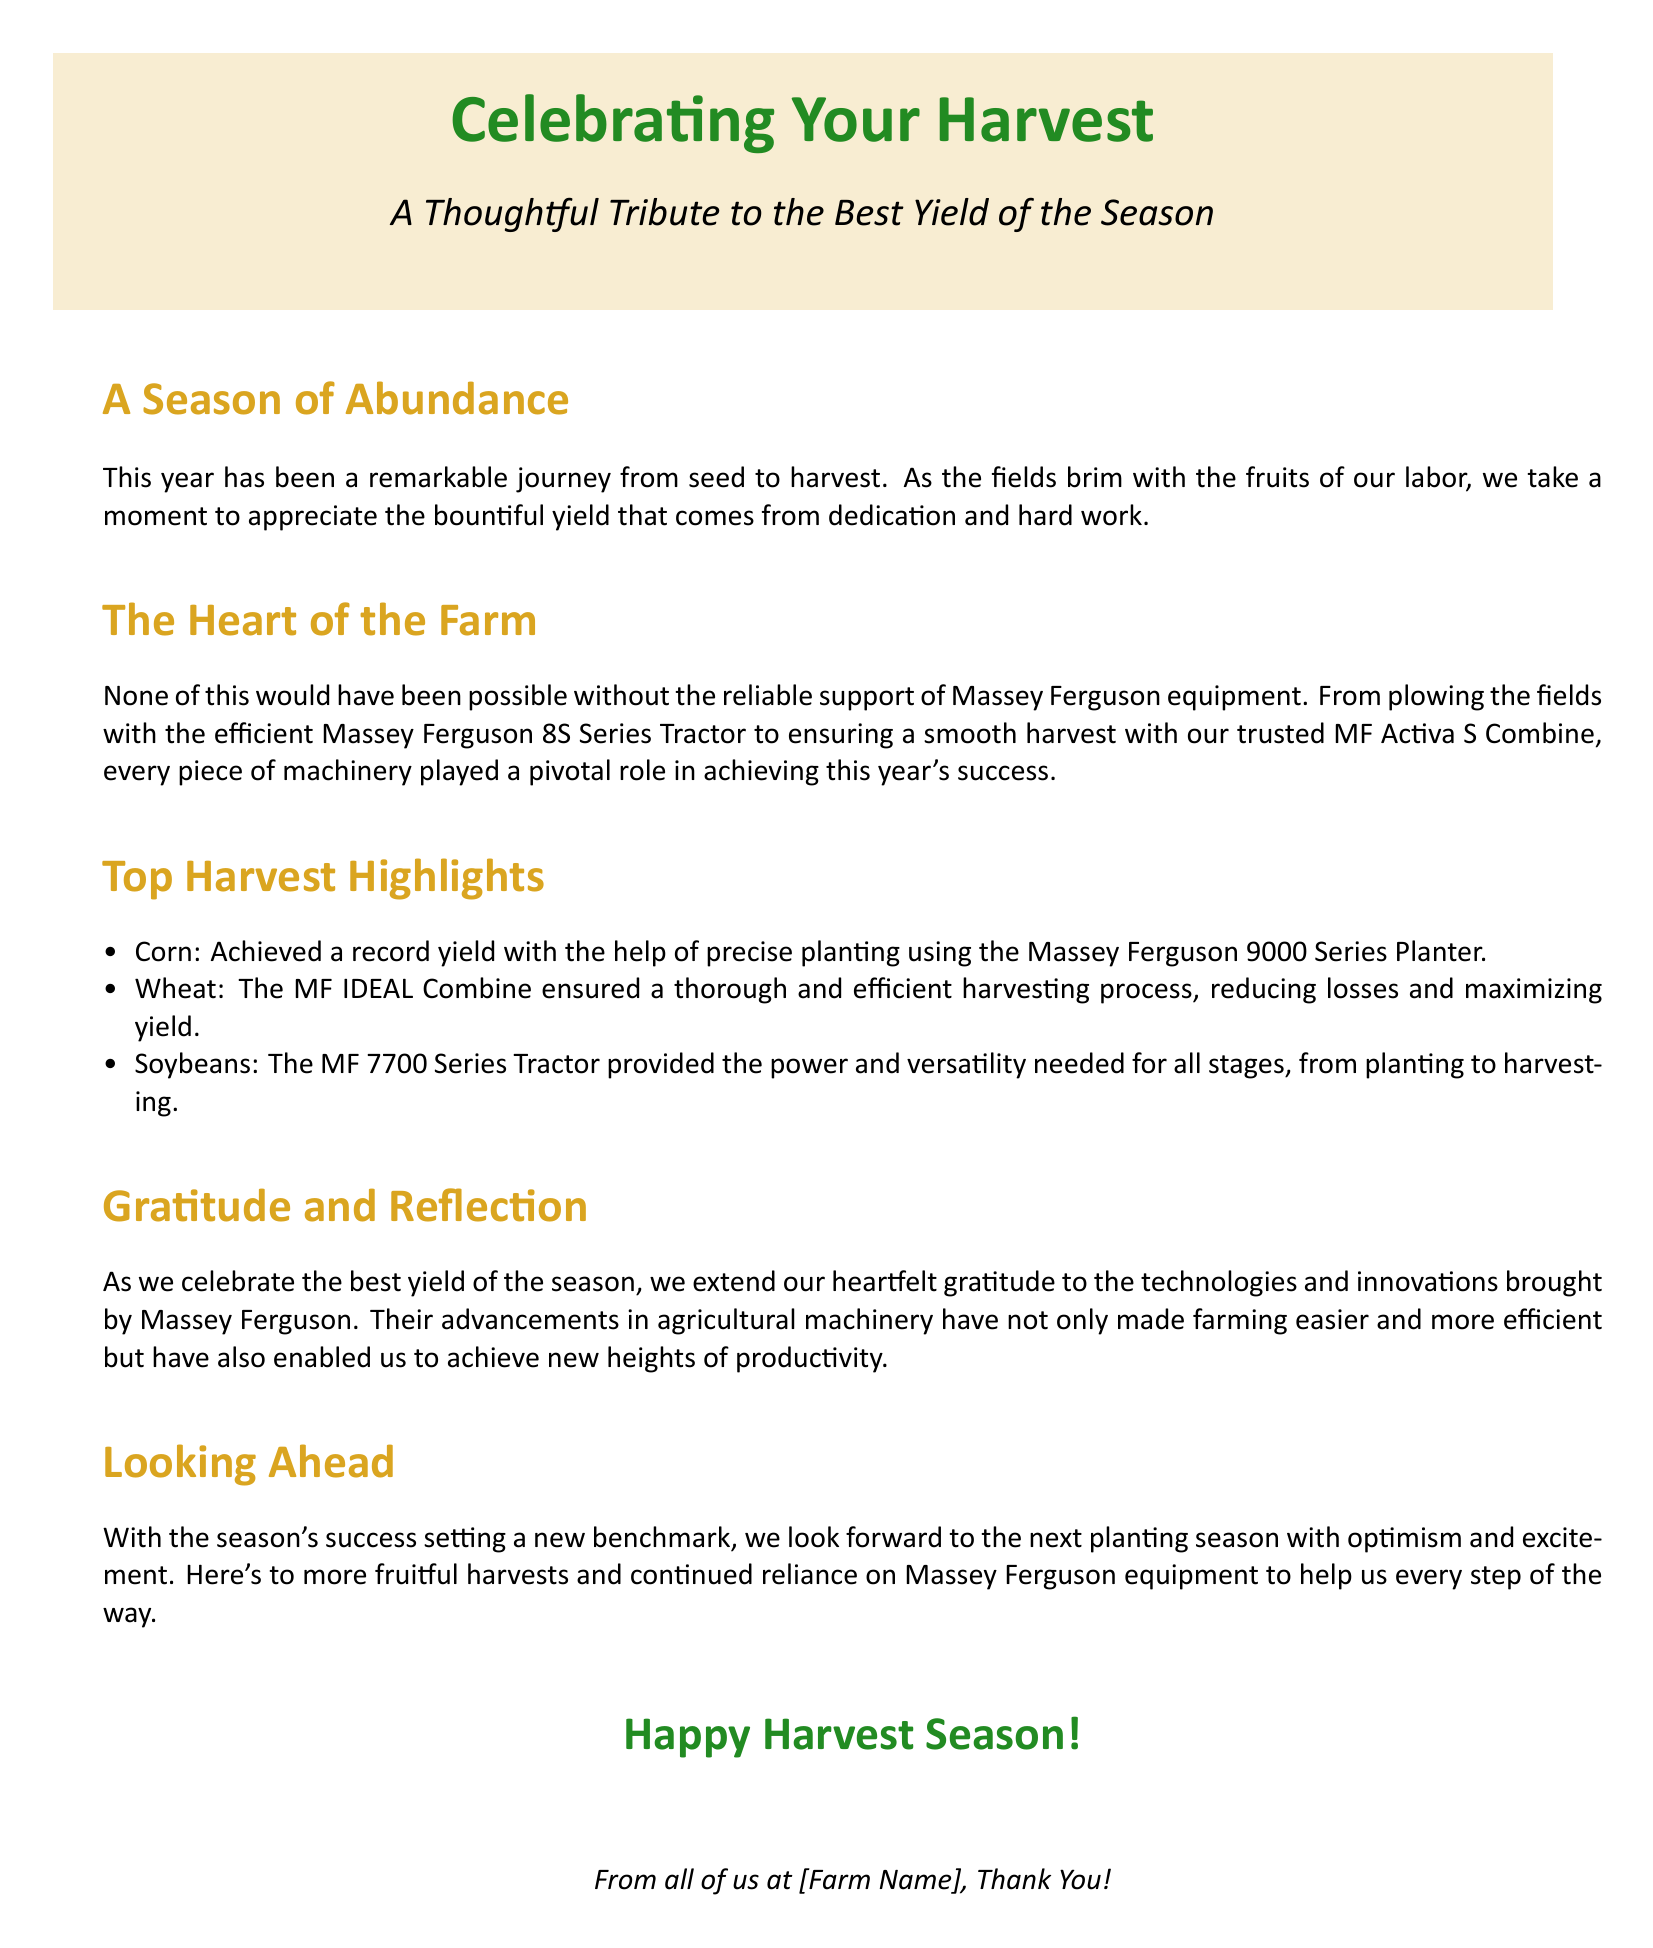What is the title of the card? The title is prominently displayed at the top of the document.
Answer: Celebrating Your Harvest What is the main color theme of the card? The card uses specific colors mentioned throughout the content.
Answer: Harvest gold Which Massey Ferguson series is mentioned for planting? The text refers specifically to a series used for planting tasks.
Answer: Massey Ferguson 9000 Series Planter What crop achieved a record yield? The document highlights a particular crop's success due to planting efficiency.
Answer: Corn What machinery is credited for efficient wheat harvesting? The card specifies which Massey Ferguson equipment facilitated the wheat harvest.
Answer: MF IDEAL Combine How does the document express gratitude? The gratitude is directed towards technological advancements that supported the harvest.
Answer: Heartfelt gratitude What sentiment is conveyed about future harvests? The document expresses an optimistic outlook for forthcoming seasons.
Answer: Optimism and excitement Which Massey Ferguson series is noted for versatility from planting to harvesting? A specific tractor series is highlighted for its multi-stage capabilities.
Answer: MF 7700 Series Tractor Who extends thanks at the end of the card? The document closes with a message of thanks from a specific group.
Answer: All of us at [Farm Name] 